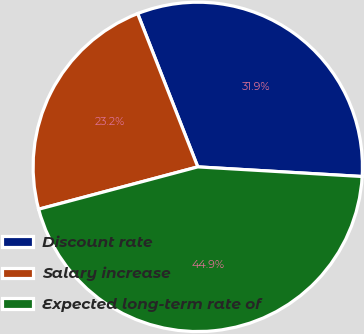Convert chart to OTSL. <chart><loc_0><loc_0><loc_500><loc_500><pie_chart><fcel>Discount rate<fcel>Salary increase<fcel>Expected long-term rate of<nl><fcel>31.88%<fcel>23.19%<fcel>44.93%<nl></chart> 